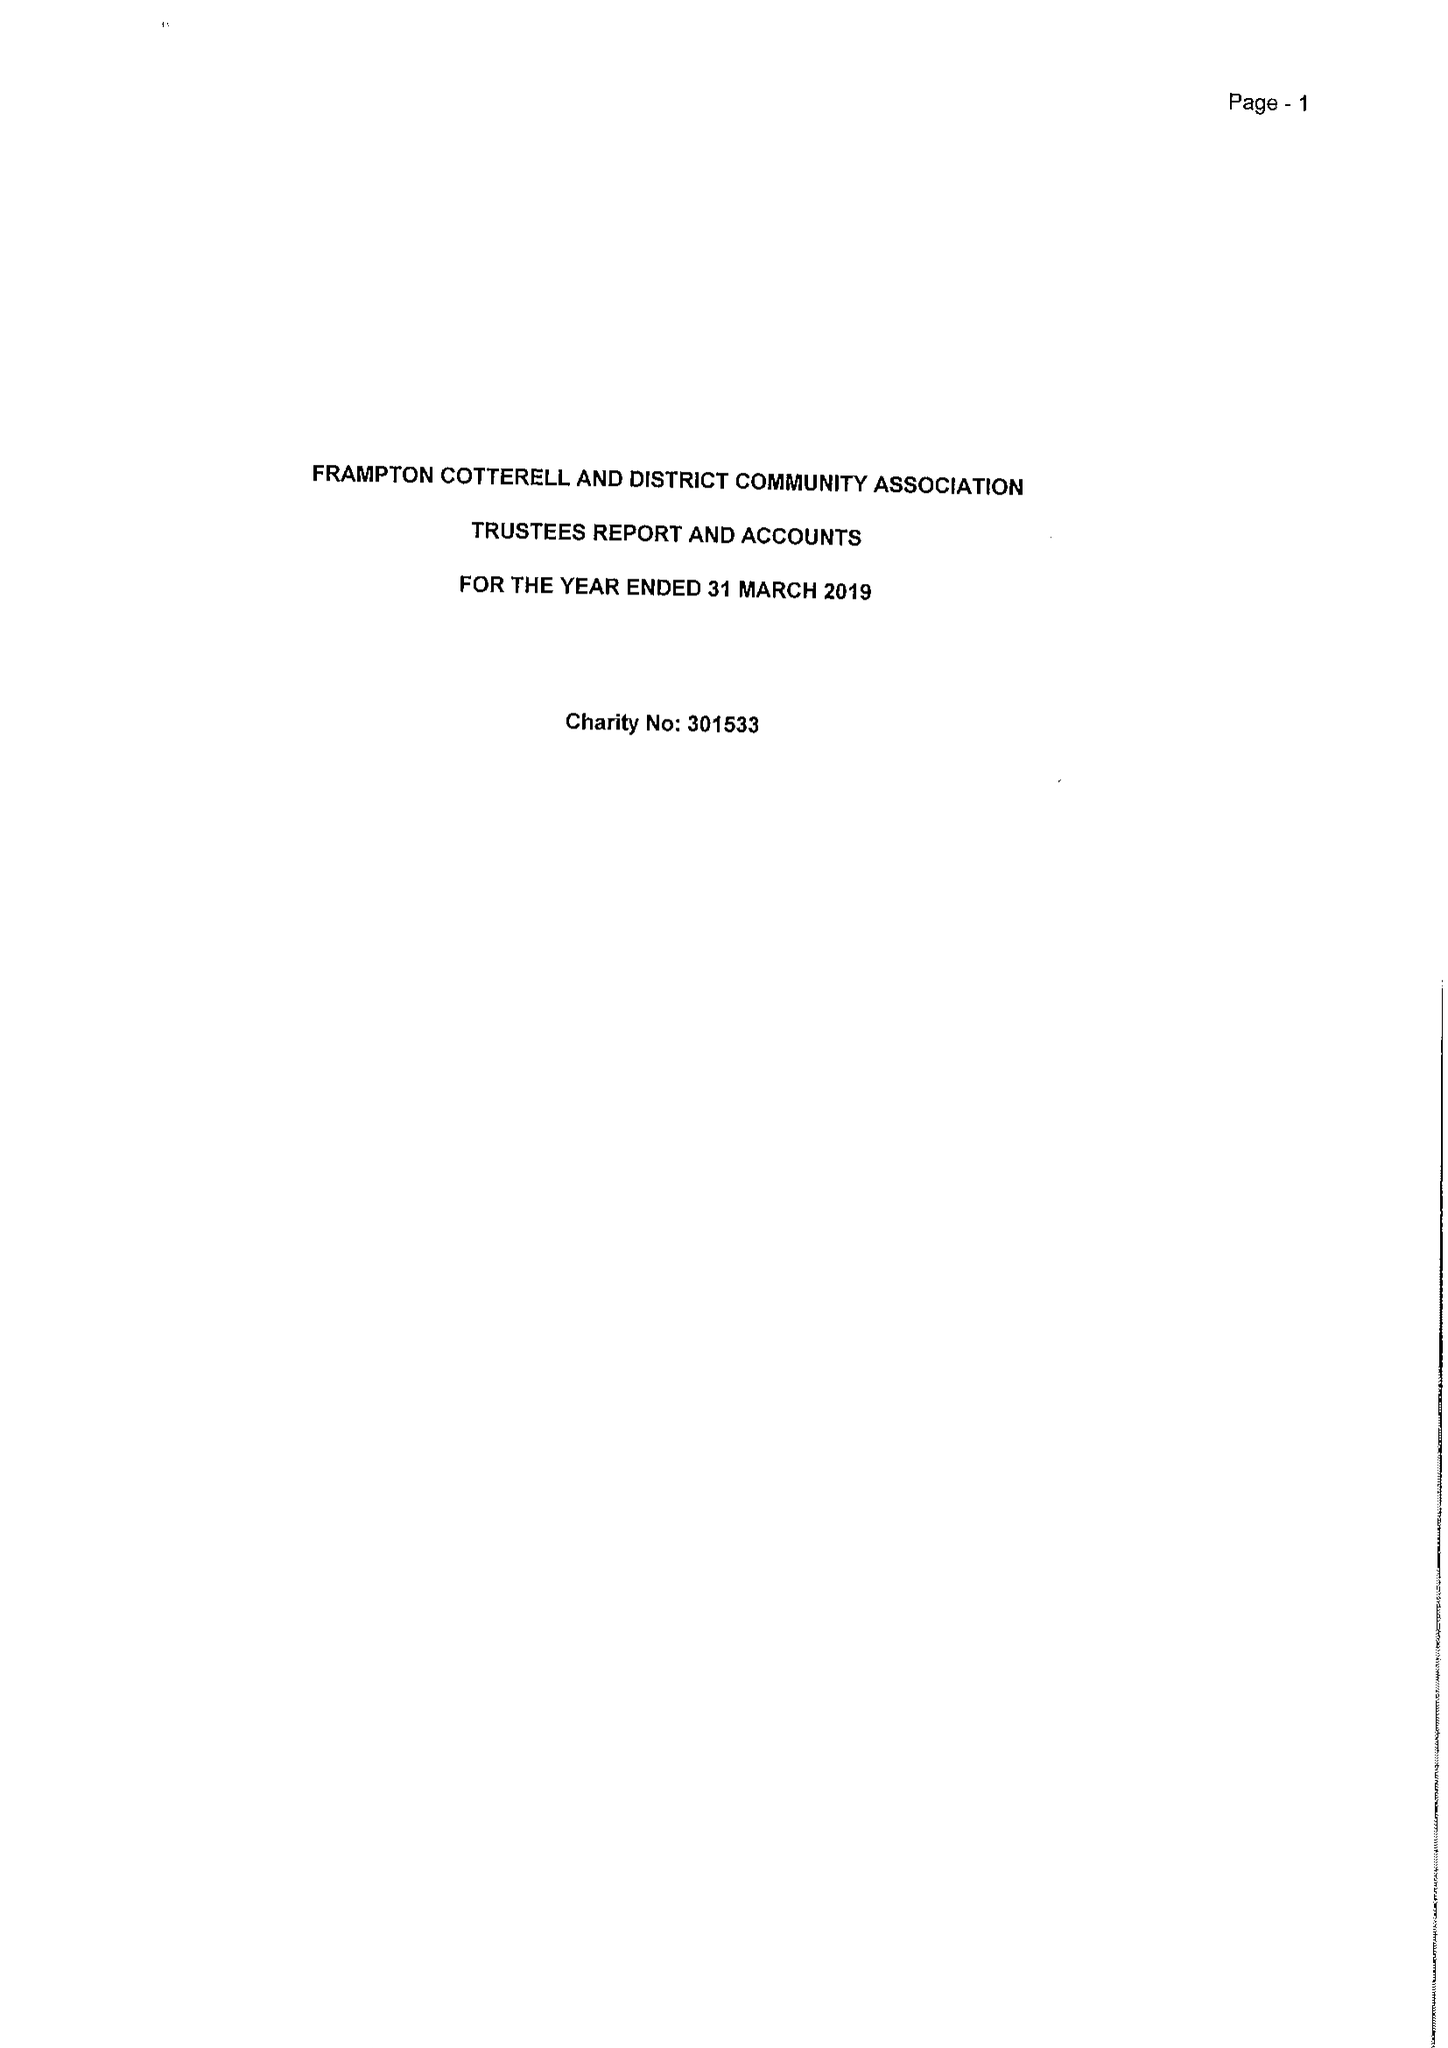What is the value for the income_annually_in_british_pounds?
Answer the question using a single word or phrase. 40238.00 